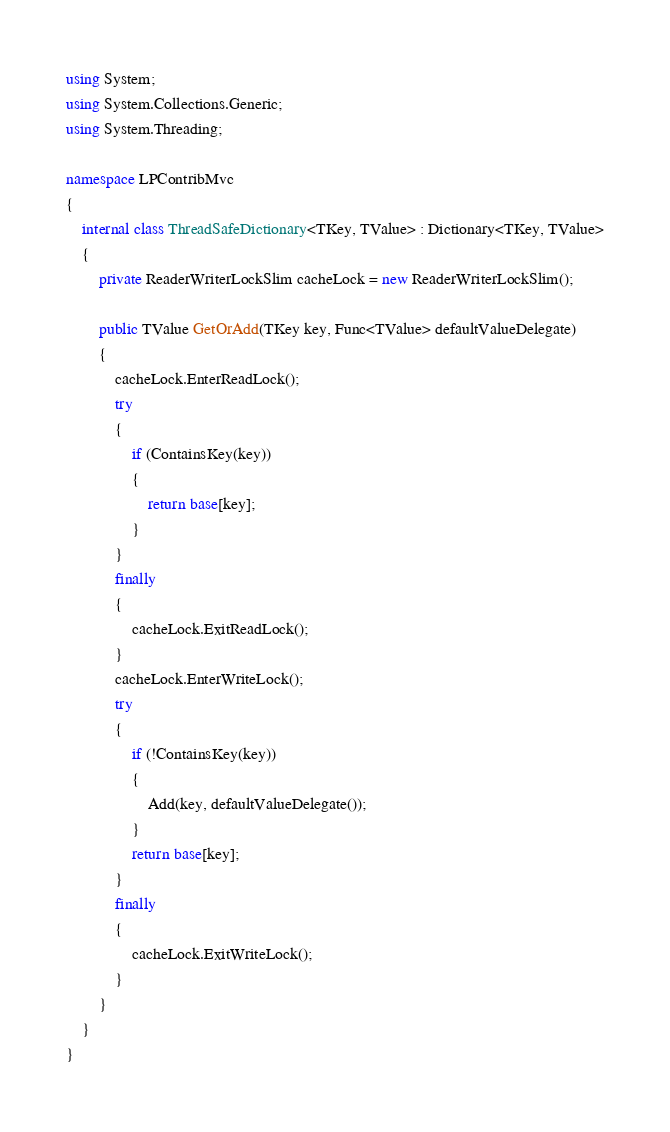<code> <loc_0><loc_0><loc_500><loc_500><_C#_>using System;
using System.Collections.Generic;
using System.Threading;

namespace LPContribMvc
{
	internal class ThreadSafeDictionary<TKey, TValue> : Dictionary<TKey, TValue>
	{
		private ReaderWriterLockSlim cacheLock = new ReaderWriterLockSlim();

		public TValue GetOrAdd(TKey key, Func<TValue> defaultValueDelegate)
		{
			cacheLock.EnterReadLock();
			try
			{
				if (ContainsKey(key))
				{
					return base[key];
				}
			}
			finally
			{
				cacheLock.ExitReadLock();
			}
			cacheLock.EnterWriteLock();
			try
			{
				if (!ContainsKey(key))
				{
					Add(key, defaultValueDelegate());
				}
				return base[key];
			}
			finally
			{
				cacheLock.ExitWriteLock();
			}
		}
	}
}
</code> 